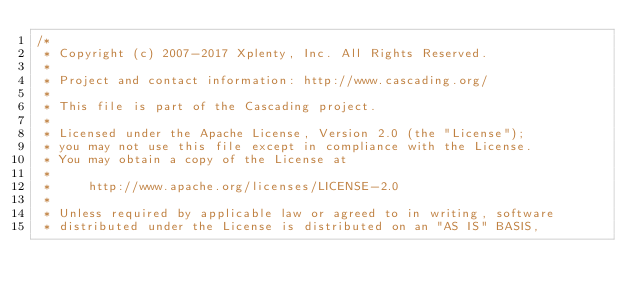<code> <loc_0><loc_0><loc_500><loc_500><_Java_>/*
 * Copyright (c) 2007-2017 Xplenty, Inc. All Rights Reserved.
 *
 * Project and contact information: http://www.cascading.org/
 *
 * This file is part of the Cascading project.
 *
 * Licensed under the Apache License, Version 2.0 (the "License");
 * you may not use this file except in compliance with the License.
 * You may obtain a copy of the License at
 *
 *     http://www.apache.org/licenses/LICENSE-2.0
 *
 * Unless required by applicable law or agreed to in writing, software
 * distributed under the License is distributed on an "AS IS" BASIS,</code> 